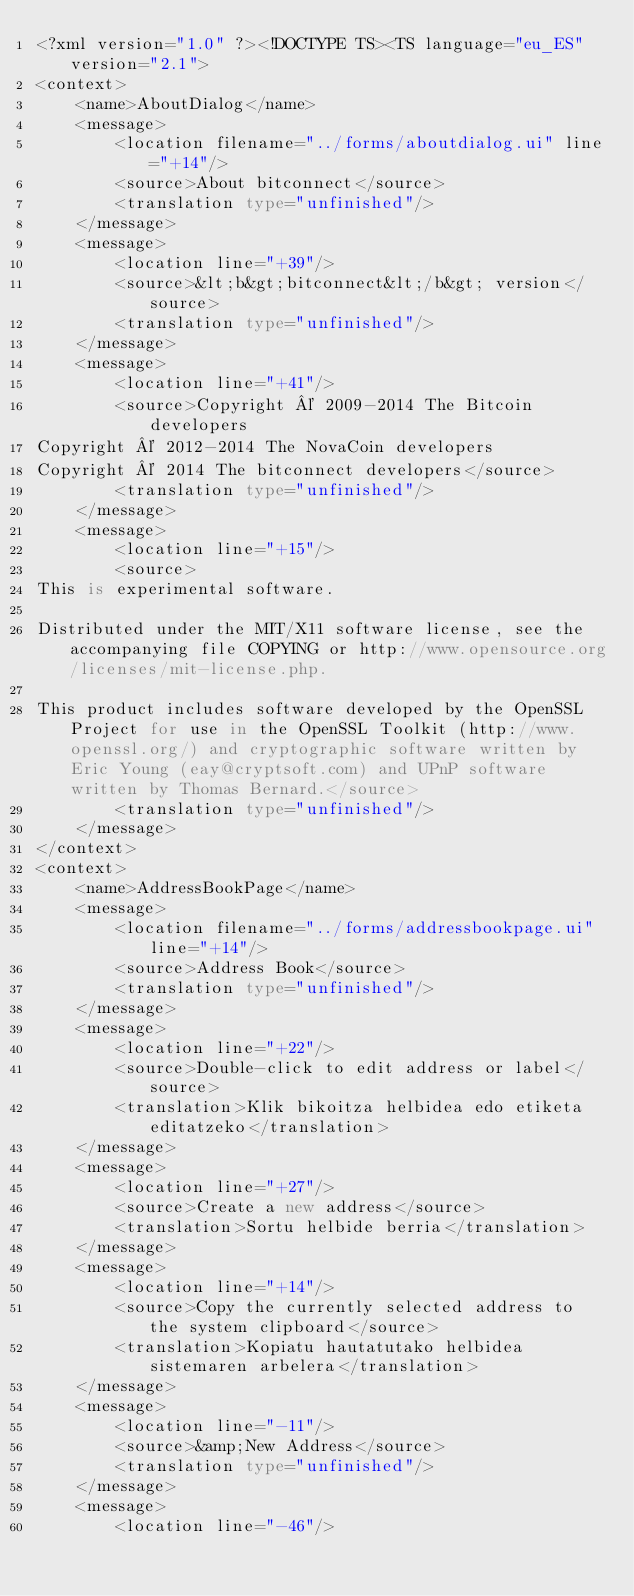Convert code to text. <code><loc_0><loc_0><loc_500><loc_500><_TypeScript_><?xml version="1.0" ?><!DOCTYPE TS><TS language="eu_ES" version="2.1">
<context>
    <name>AboutDialog</name>
    <message>
        <location filename="../forms/aboutdialog.ui" line="+14"/>
        <source>About bitconnect</source>
        <translation type="unfinished"/>
    </message>
    <message>
        <location line="+39"/>
        <source>&lt;b&gt;bitconnect&lt;/b&gt; version</source>
        <translation type="unfinished"/>
    </message>
    <message>
        <location line="+41"/>
        <source>Copyright © 2009-2014 The Bitcoin developers
Copyright © 2012-2014 The NovaCoin developers
Copyright © 2014 The bitconnect developers</source>
        <translation type="unfinished"/>
    </message>
    <message>
        <location line="+15"/>
        <source>
This is experimental software.

Distributed under the MIT/X11 software license, see the accompanying file COPYING or http://www.opensource.org/licenses/mit-license.php.

This product includes software developed by the OpenSSL Project for use in the OpenSSL Toolkit (http://www.openssl.org/) and cryptographic software written by Eric Young (eay@cryptsoft.com) and UPnP software written by Thomas Bernard.</source>
        <translation type="unfinished"/>
    </message>
</context>
<context>
    <name>AddressBookPage</name>
    <message>
        <location filename="../forms/addressbookpage.ui" line="+14"/>
        <source>Address Book</source>
        <translation type="unfinished"/>
    </message>
    <message>
        <location line="+22"/>
        <source>Double-click to edit address or label</source>
        <translation>Klik bikoitza helbidea edo etiketa editatzeko</translation>
    </message>
    <message>
        <location line="+27"/>
        <source>Create a new address</source>
        <translation>Sortu helbide berria</translation>
    </message>
    <message>
        <location line="+14"/>
        <source>Copy the currently selected address to the system clipboard</source>
        <translation>Kopiatu hautatutako helbidea sistemaren arbelera</translation>
    </message>
    <message>
        <location line="-11"/>
        <source>&amp;New Address</source>
        <translation type="unfinished"/>
    </message>
    <message>
        <location line="-46"/></code> 